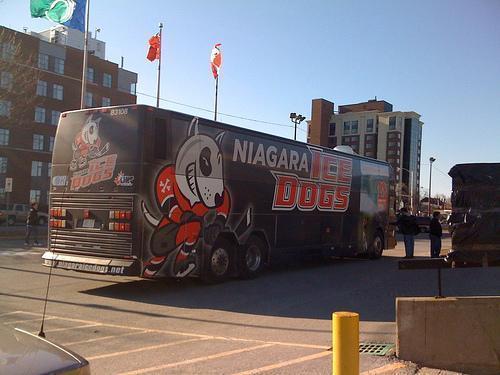What sport is the cartoon dog playing?
Answer the question by selecting the correct answer among the 4 following choices and explain your choice with a short sentence. The answer should be formatted with the following format: `Answer: choice
Rationale: rationale.`
Options: Baseball, ice hockey, golf, lacrosse. Answer: ice hockey.
Rationale: The team is niagara ice dogs. 